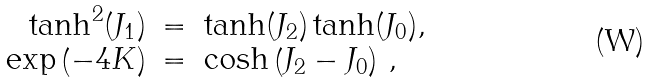<formula> <loc_0><loc_0><loc_500><loc_500>\begin{array} { r c l } \tanh ^ { 2 } ( J _ { 1 } ) & = & \tanh ( J _ { 2 } ) \tanh ( J _ { 0 } ) , \\ \exp \left ( - 4 K \right ) & = & \cosh \left ( J _ { 2 } - J _ { 0 } \right ) \, , \end{array}</formula> 